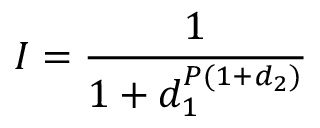<formula> <loc_0><loc_0><loc_500><loc_500>I = \frac { 1 } { 1 + d _ { 1 } ^ { P ( 1 + d _ { 2 } ) } }</formula> 